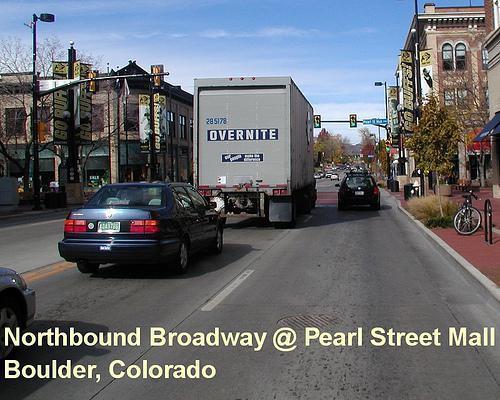How many vehicles are shown?
Give a very brief answer. 4. How many red cars do you see?
Give a very brief answer. 0. How many cars are there?
Give a very brief answer. 2. 